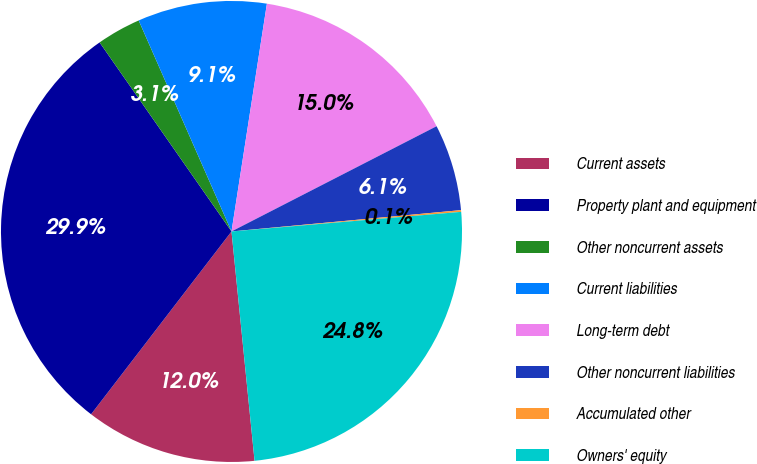Convert chart to OTSL. <chart><loc_0><loc_0><loc_500><loc_500><pie_chart><fcel>Current assets<fcel>Property plant and equipment<fcel>Other noncurrent assets<fcel>Current liabilities<fcel>Long-term debt<fcel>Other noncurrent liabilities<fcel>Accumulated other<fcel>Owners' equity<nl><fcel>12.02%<fcel>29.88%<fcel>3.1%<fcel>9.05%<fcel>15.0%<fcel>6.07%<fcel>0.12%<fcel>24.76%<nl></chart> 